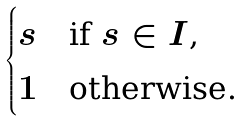<formula> <loc_0><loc_0><loc_500><loc_500>\begin{cases} s & \text {if $s \in I$,} \\ 1 & \text {otherwise.} \end{cases}</formula> 